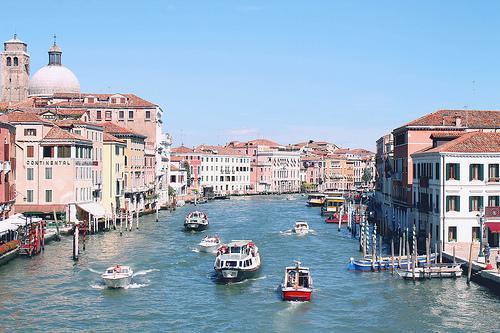How many domes are in the picture?
Give a very brief answer. 1. How many of the boats are cruiseliners?
Give a very brief answer. 0. 